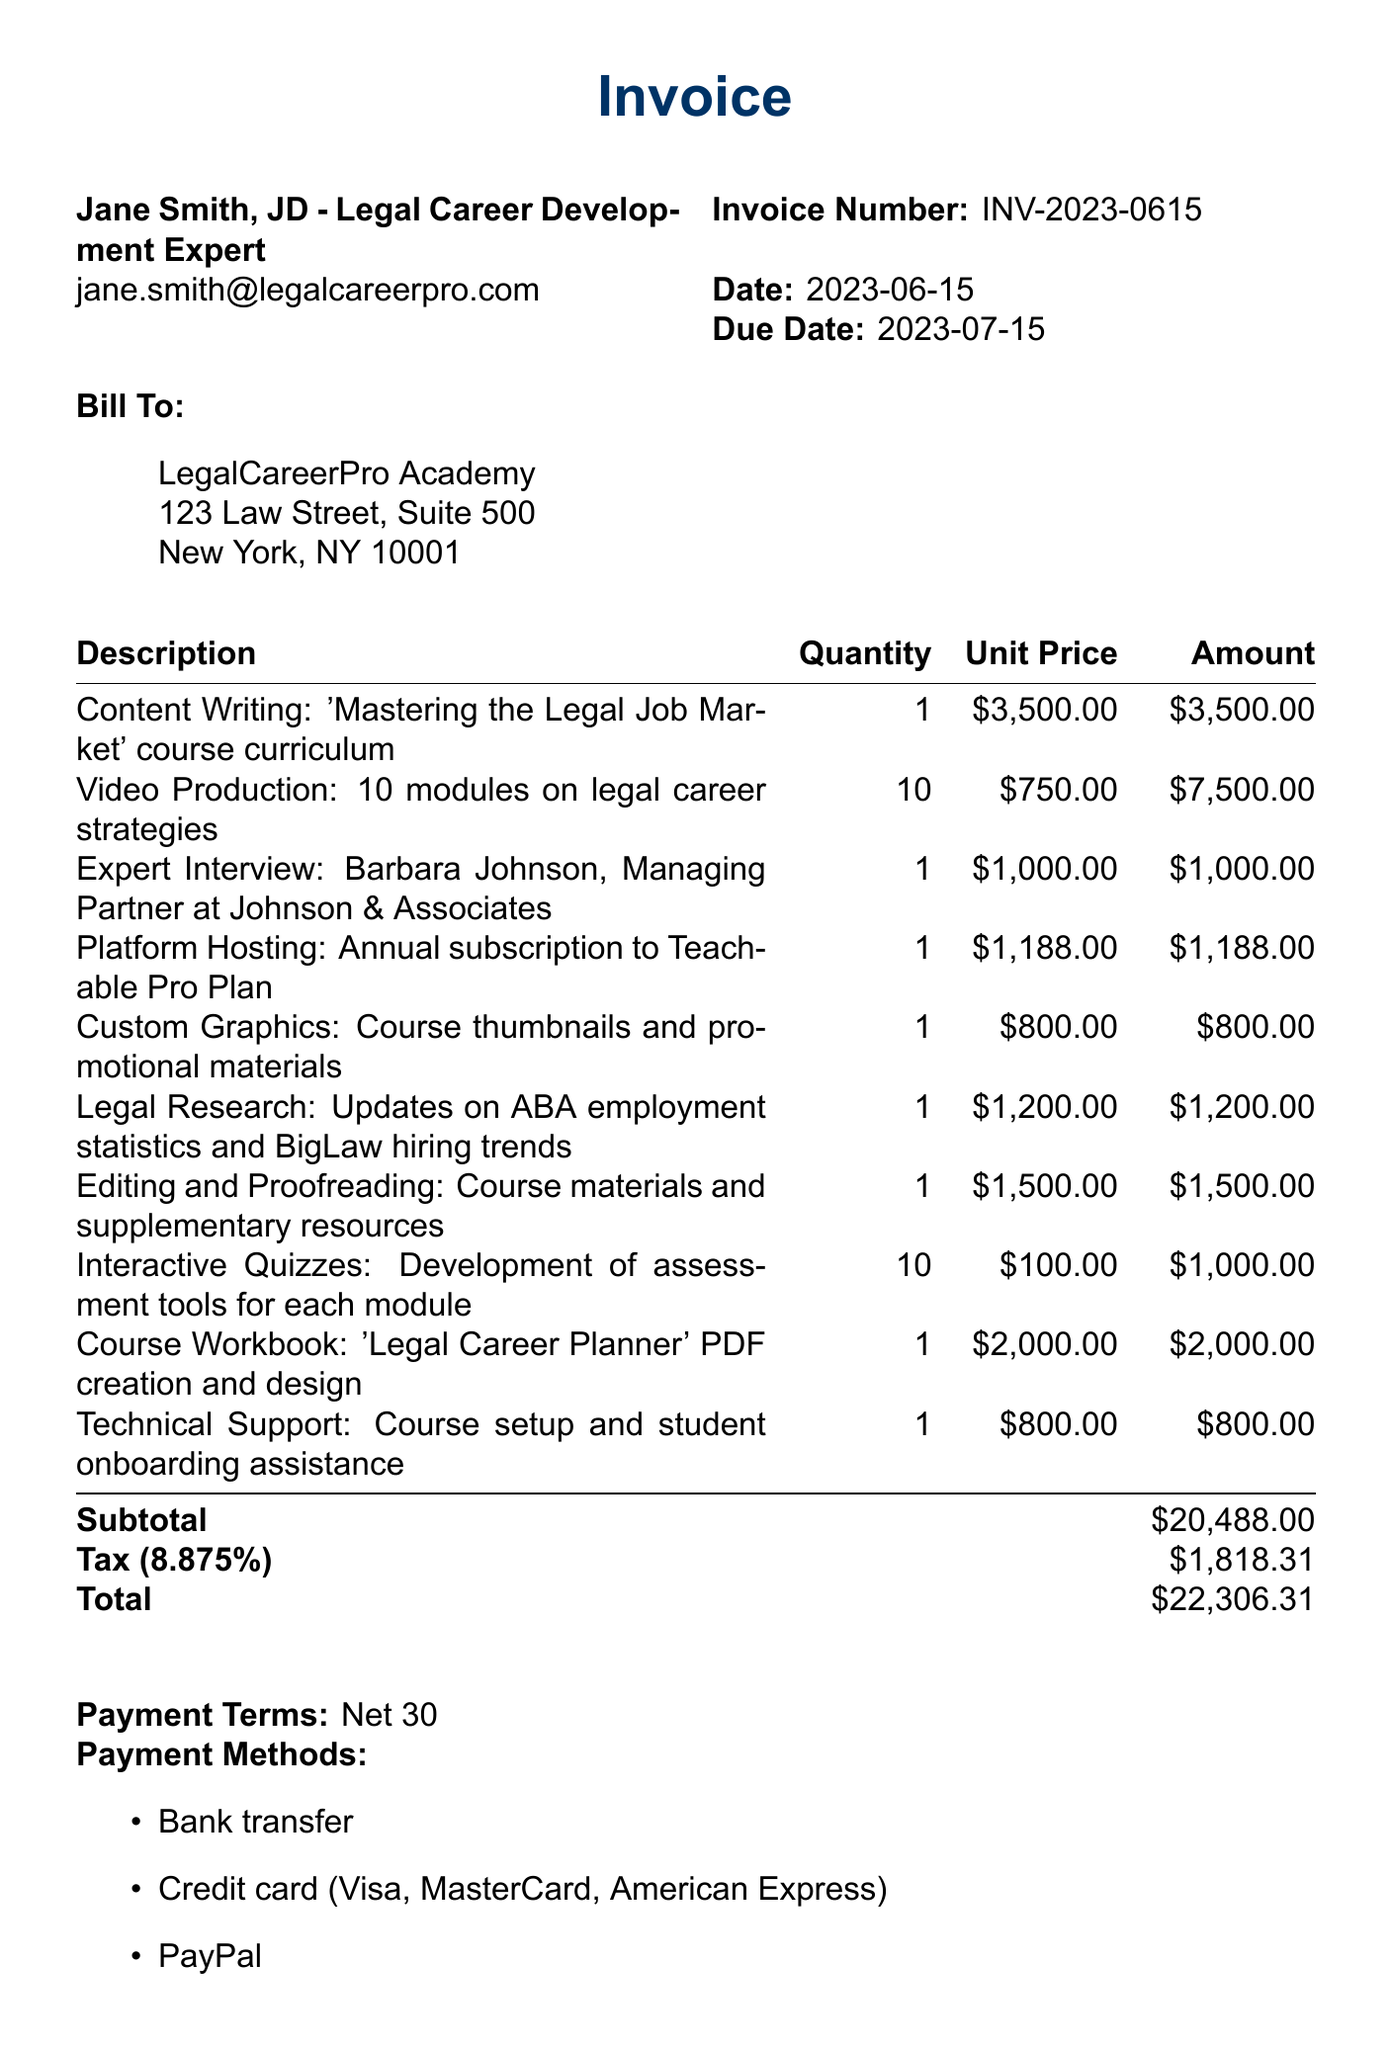What is the invoice number? The invoice number is listed at the top of the document.
Answer: INV-2023-0615 What is the total amount due? The total amount due is calculated at the bottom of the invoice.
Answer: $22,306.31 Who is the service provider? The service provider is mentioned at the beginning of the document.
Answer: Jane Smith, JD - Legal Career Development Expert What is the date of the invoice? The date of the invoice is provided near the invoice number.
Answer: 2023-06-15 What is the quantity of interactive quizzes developed? The quantity is specified in the line items section.
Answer: 10 What is the unit price for content writing? The unit price for content writing is detailed in the invoice line items.
Answer: $3,500.00 What is the tax rate applied in this invoice? The tax rate is mentioned in the summary of the invoice.
Answer: 8.875% What does the payment terms state? The payment terms are specified at the bottom of the document.
Answer: Net 30 What is the client name? The client name is listed in the billing section of the document.
Answer: LegalCareerPro Academy 